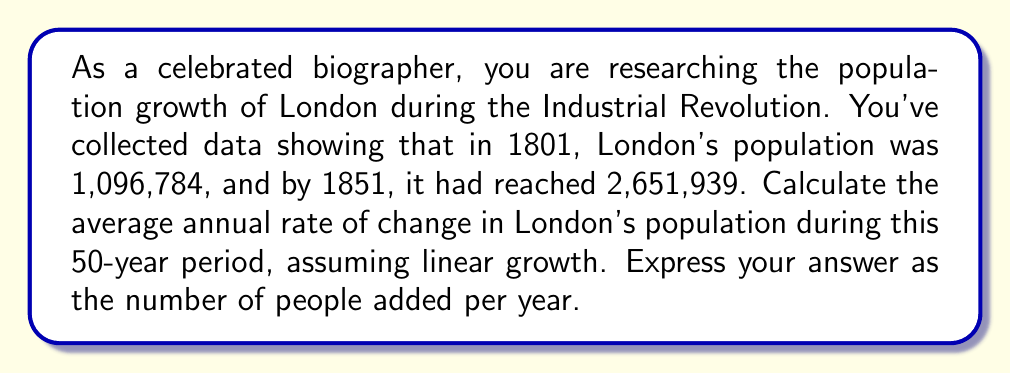Could you help me with this problem? To solve this problem, we'll use the linear rate of change formula:

$$ \text{Rate of Change} = \frac{\text{Change in Y}}{\text{Change in X}} $$

Where Y represents the population and X represents time.

1. Calculate the total change in population:
   $\Delta Y = 2,651,939 - 1,096,784 = 1,555,155$

2. Determine the time interval:
   $\Delta X = 1851 - 1801 = 50$ years

3. Apply the rate of change formula:
   $$ \text{Rate of Change} = \frac{1,555,155}{50} = 31,103.1 $$

Therefore, the average annual rate of change in London's population during this period was approximately 31,103 people per year.

This linear model provides a simplified view of population growth, which aligns with the biographer's belief in avoiding fictional distortions of historical truths. However, it's important to note that actual population growth is often non-linear and influenced by various factors such as birth rates, death rates, and migration patterns.
Answer: The average annual rate of change in London's population from 1801 to 1851 was approximately 31,103 people per year. 